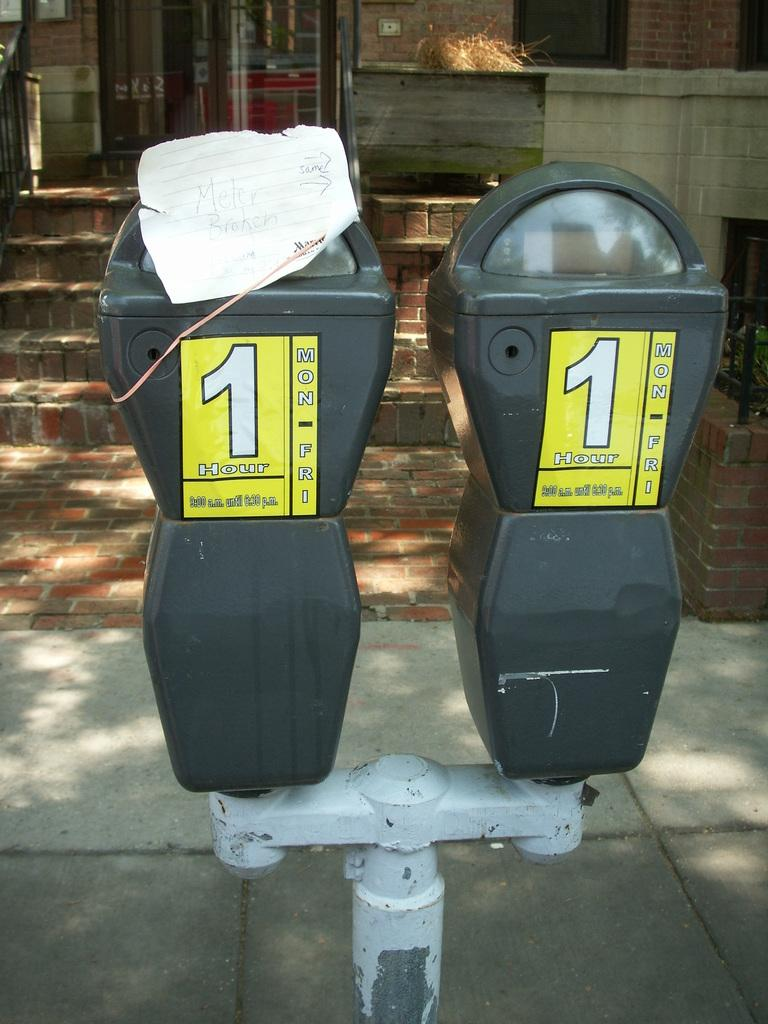What can be seen on the pole in the image? There are two meters on a pole in the image. What is visible in the background of the image? There is a building with brick stairs in the background. What type of surface is at the bottom of the image? There are tiles at the bottom of the image. What is the mind of the maid doing in the image? There is no mind or maid present in the image. Is there a road visible in the image? No, there is no road visible in the image. 